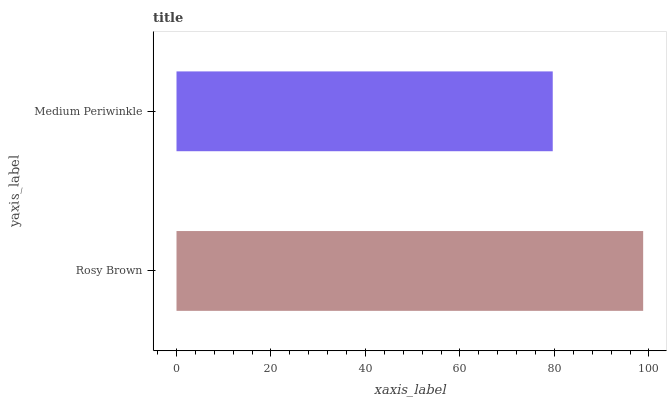Is Medium Periwinkle the minimum?
Answer yes or no. Yes. Is Rosy Brown the maximum?
Answer yes or no. Yes. Is Medium Periwinkle the maximum?
Answer yes or no. No. Is Rosy Brown greater than Medium Periwinkle?
Answer yes or no. Yes. Is Medium Periwinkle less than Rosy Brown?
Answer yes or no. Yes. Is Medium Periwinkle greater than Rosy Brown?
Answer yes or no. No. Is Rosy Brown less than Medium Periwinkle?
Answer yes or no. No. Is Rosy Brown the high median?
Answer yes or no. Yes. Is Medium Periwinkle the low median?
Answer yes or no. Yes. Is Medium Periwinkle the high median?
Answer yes or no. No. Is Rosy Brown the low median?
Answer yes or no. No. 